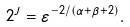<formula> <loc_0><loc_0><loc_500><loc_500>2 ^ { J } = \varepsilon ^ { - 2 / ( \alpha + \beta + 2 ) } .</formula> 